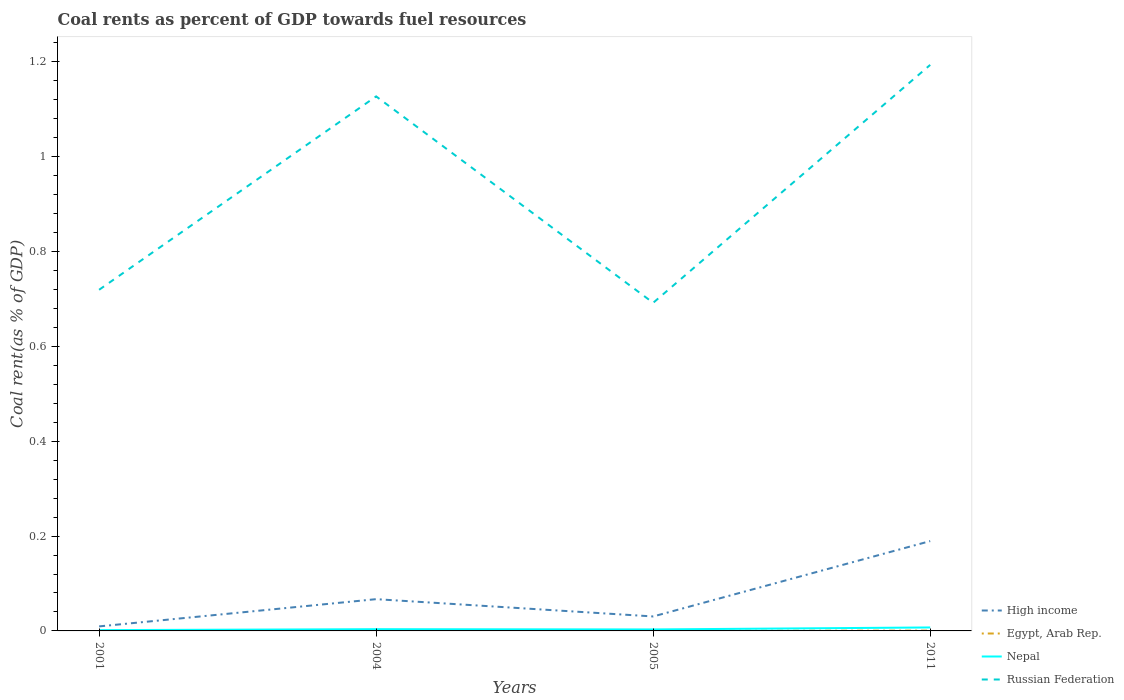Is the number of lines equal to the number of legend labels?
Make the answer very short. Yes. Across all years, what is the maximum coal rent in Nepal?
Make the answer very short. 0. In which year was the coal rent in Russian Federation maximum?
Keep it short and to the point. 2005. What is the total coal rent in High income in the graph?
Offer a very short reply. -0.18. What is the difference between the highest and the second highest coal rent in Nepal?
Offer a very short reply. 0.01. Is the coal rent in High income strictly greater than the coal rent in Nepal over the years?
Make the answer very short. No. How many lines are there?
Give a very brief answer. 4. Are the values on the major ticks of Y-axis written in scientific E-notation?
Offer a terse response. No. How are the legend labels stacked?
Offer a terse response. Vertical. What is the title of the graph?
Provide a succinct answer. Coal rents as percent of GDP towards fuel resources. Does "Syrian Arab Republic" appear as one of the legend labels in the graph?
Your answer should be very brief. No. What is the label or title of the X-axis?
Provide a short and direct response. Years. What is the label or title of the Y-axis?
Give a very brief answer. Coal rent(as % of GDP). What is the Coal rent(as % of GDP) in High income in 2001?
Ensure brevity in your answer.  0.01. What is the Coal rent(as % of GDP) in Egypt, Arab Rep. in 2001?
Your answer should be compact. 1.02739128441411e-6. What is the Coal rent(as % of GDP) in Nepal in 2001?
Offer a very short reply. 0. What is the Coal rent(as % of GDP) of Russian Federation in 2001?
Keep it short and to the point. 0.72. What is the Coal rent(as % of GDP) in High income in 2004?
Your answer should be compact. 0.07. What is the Coal rent(as % of GDP) of Egypt, Arab Rep. in 2004?
Make the answer very short. 0. What is the Coal rent(as % of GDP) of Nepal in 2004?
Your answer should be compact. 0. What is the Coal rent(as % of GDP) in Russian Federation in 2004?
Ensure brevity in your answer.  1.13. What is the Coal rent(as % of GDP) in High income in 2005?
Your answer should be compact. 0.03. What is the Coal rent(as % of GDP) of Egypt, Arab Rep. in 2005?
Provide a short and direct response. 0. What is the Coal rent(as % of GDP) of Nepal in 2005?
Your answer should be very brief. 0. What is the Coal rent(as % of GDP) in Russian Federation in 2005?
Offer a terse response. 0.69. What is the Coal rent(as % of GDP) in High income in 2011?
Offer a terse response. 0.19. What is the Coal rent(as % of GDP) in Egypt, Arab Rep. in 2011?
Provide a short and direct response. 0. What is the Coal rent(as % of GDP) of Nepal in 2011?
Your answer should be very brief. 0.01. What is the Coal rent(as % of GDP) of Russian Federation in 2011?
Give a very brief answer. 1.19. Across all years, what is the maximum Coal rent(as % of GDP) of High income?
Your answer should be very brief. 0.19. Across all years, what is the maximum Coal rent(as % of GDP) in Egypt, Arab Rep.?
Your response must be concise. 0. Across all years, what is the maximum Coal rent(as % of GDP) in Nepal?
Give a very brief answer. 0.01. Across all years, what is the maximum Coal rent(as % of GDP) in Russian Federation?
Keep it short and to the point. 1.19. Across all years, what is the minimum Coal rent(as % of GDP) in High income?
Offer a very short reply. 0.01. Across all years, what is the minimum Coal rent(as % of GDP) of Egypt, Arab Rep.?
Offer a terse response. 1.02739128441411e-6. Across all years, what is the minimum Coal rent(as % of GDP) of Nepal?
Make the answer very short. 0. Across all years, what is the minimum Coal rent(as % of GDP) of Russian Federation?
Ensure brevity in your answer.  0.69. What is the total Coal rent(as % of GDP) in High income in the graph?
Keep it short and to the point. 0.3. What is the total Coal rent(as % of GDP) of Egypt, Arab Rep. in the graph?
Provide a succinct answer. 0. What is the total Coal rent(as % of GDP) in Nepal in the graph?
Your answer should be compact. 0.02. What is the total Coal rent(as % of GDP) in Russian Federation in the graph?
Offer a very short reply. 3.73. What is the difference between the Coal rent(as % of GDP) in High income in 2001 and that in 2004?
Give a very brief answer. -0.06. What is the difference between the Coal rent(as % of GDP) in Egypt, Arab Rep. in 2001 and that in 2004?
Offer a very short reply. -0. What is the difference between the Coal rent(as % of GDP) in Nepal in 2001 and that in 2004?
Provide a short and direct response. -0. What is the difference between the Coal rent(as % of GDP) of Russian Federation in 2001 and that in 2004?
Your answer should be compact. -0.41. What is the difference between the Coal rent(as % of GDP) of High income in 2001 and that in 2005?
Provide a succinct answer. -0.02. What is the difference between the Coal rent(as % of GDP) in Egypt, Arab Rep. in 2001 and that in 2005?
Your answer should be compact. -0. What is the difference between the Coal rent(as % of GDP) of Nepal in 2001 and that in 2005?
Make the answer very short. -0. What is the difference between the Coal rent(as % of GDP) in Russian Federation in 2001 and that in 2005?
Your answer should be very brief. 0.03. What is the difference between the Coal rent(as % of GDP) of High income in 2001 and that in 2011?
Your answer should be very brief. -0.18. What is the difference between the Coal rent(as % of GDP) of Egypt, Arab Rep. in 2001 and that in 2011?
Keep it short and to the point. -0. What is the difference between the Coal rent(as % of GDP) of Nepal in 2001 and that in 2011?
Give a very brief answer. -0.01. What is the difference between the Coal rent(as % of GDP) of Russian Federation in 2001 and that in 2011?
Your answer should be very brief. -0.47. What is the difference between the Coal rent(as % of GDP) of High income in 2004 and that in 2005?
Provide a short and direct response. 0.04. What is the difference between the Coal rent(as % of GDP) of Egypt, Arab Rep. in 2004 and that in 2005?
Make the answer very short. 0. What is the difference between the Coal rent(as % of GDP) of Nepal in 2004 and that in 2005?
Give a very brief answer. 0. What is the difference between the Coal rent(as % of GDP) in Russian Federation in 2004 and that in 2005?
Offer a terse response. 0.44. What is the difference between the Coal rent(as % of GDP) of High income in 2004 and that in 2011?
Give a very brief answer. -0.12. What is the difference between the Coal rent(as % of GDP) of Nepal in 2004 and that in 2011?
Offer a terse response. -0. What is the difference between the Coal rent(as % of GDP) of Russian Federation in 2004 and that in 2011?
Make the answer very short. -0.07. What is the difference between the Coal rent(as % of GDP) of High income in 2005 and that in 2011?
Your response must be concise. -0.16. What is the difference between the Coal rent(as % of GDP) in Egypt, Arab Rep. in 2005 and that in 2011?
Your response must be concise. -0. What is the difference between the Coal rent(as % of GDP) in Nepal in 2005 and that in 2011?
Your answer should be compact. -0. What is the difference between the Coal rent(as % of GDP) in Russian Federation in 2005 and that in 2011?
Keep it short and to the point. -0.5. What is the difference between the Coal rent(as % of GDP) in High income in 2001 and the Coal rent(as % of GDP) in Egypt, Arab Rep. in 2004?
Your answer should be compact. 0.01. What is the difference between the Coal rent(as % of GDP) of High income in 2001 and the Coal rent(as % of GDP) of Nepal in 2004?
Ensure brevity in your answer.  0.01. What is the difference between the Coal rent(as % of GDP) of High income in 2001 and the Coal rent(as % of GDP) of Russian Federation in 2004?
Give a very brief answer. -1.12. What is the difference between the Coal rent(as % of GDP) in Egypt, Arab Rep. in 2001 and the Coal rent(as % of GDP) in Nepal in 2004?
Provide a succinct answer. -0. What is the difference between the Coal rent(as % of GDP) of Egypt, Arab Rep. in 2001 and the Coal rent(as % of GDP) of Russian Federation in 2004?
Ensure brevity in your answer.  -1.13. What is the difference between the Coal rent(as % of GDP) in Nepal in 2001 and the Coal rent(as % of GDP) in Russian Federation in 2004?
Provide a short and direct response. -1.13. What is the difference between the Coal rent(as % of GDP) of High income in 2001 and the Coal rent(as % of GDP) of Egypt, Arab Rep. in 2005?
Ensure brevity in your answer.  0.01. What is the difference between the Coal rent(as % of GDP) in High income in 2001 and the Coal rent(as % of GDP) in Nepal in 2005?
Ensure brevity in your answer.  0.01. What is the difference between the Coal rent(as % of GDP) in High income in 2001 and the Coal rent(as % of GDP) in Russian Federation in 2005?
Offer a terse response. -0.68. What is the difference between the Coal rent(as % of GDP) in Egypt, Arab Rep. in 2001 and the Coal rent(as % of GDP) in Nepal in 2005?
Your response must be concise. -0. What is the difference between the Coal rent(as % of GDP) in Egypt, Arab Rep. in 2001 and the Coal rent(as % of GDP) in Russian Federation in 2005?
Provide a succinct answer. -0.69. What is the difference between the Coal rent(as % of GDP) of Nepal in 2001 and the Coal rent(as % of GDP) of Russian Federation in 2005?
Provide a succinct answer. -0.69. What is the difference between the Coal rent(as % of GDP) in High income in 2001 and the Coal rent(as % of GDP) in Egypt, Arab Rep. in 2011?
Keep it short and to the point. 0.01. What is the difference between the Coal rent(as % of GDP) of High income in 2001 and the Coal rent(as % of GDP) of Nepal in 2011?
Your answer should be very brief. 0. What is the difference between the Coal rent(as % of GDP) in High income in 2001 and the Coal rent(as % of GDP) in Russian Federation in 2011?
Ensure brevity in your answer.  -1.18. What is the difference between the Coal rent(as % of GDP) in Egypt, Arab Rep. in 2001 and the Coal rent(as % of GDP) in Nepal in 2011?
Keep it short and to the point. -0.01. What is the difference between the Coal rent(as % of GDP) in Egypt, Arab Rep. in 2001 and the Coal rent(as % of GDP) in Russian Federation in 2011?
Provide a short and direct response. -1.19. What is the difference between the Coal rent(as % of GDP) of Nepal in 2001 and the Coal rent(as % of GDP) of Russian Federation in 2011?
Offer a terse response. -1.19. What is the difference between the Coal rent(as % of GDP) of High income in 2004 and the Coal rent(as % of GDP) of Egypt, Arab Rep. in 2005?
Give a very brief answer. 0.07. What is the difference between the Coal rent(as % of GDP) in High income in 2004 and the Coal rent(as % of GDP) in Nepal in 2005?
Your response must be concise. 0.06. What is the difference between the Coal rent(as % of GDP) in High income in 2004 and the Coal rent(as % of GDP) in Russian Federation in 2005?
Provide a succinct answer. -0.62. What is the difference between the Coal rent(as % of GDP) of Egypt, Arab Rep. in 2004 and the Coal rent(as % of GDP) of Nepal in 2005?
Offer a very short reply. -0. What is the difference between the Coal rent(as % of GDP) of Egypt, Arab Rep. in 2004 and the Coal rent(as % of GDP) of Russian Federation in 2005?
Keep it short and to the point. -0.69. What is the difference between the Coal rent(as % of GDP) of Nepal in 2004 and the Coal rent(as % of GDP) of Russian Federation in 2005?
Your answer should be very brief. -0.69. What is the difference between the Coal rent(as % of GDP) in High income in 2004 and the Coal rent(as % of GDP) in Egypt, Arab Rep. in 2011?
Give a very brief answer. 0.07. What is the difference between the Coal rent(as % of GDP) of High income in 2004 and the Coal rent(as % of GDP) of Nepal in 2011?
Ensure brevity in your answer.  0.06. What is the difference between the Coal rent(as % of GDP) in High income in 2004 and the Coal rent(as % of GDP) in Russian Federation in 2011?
Your answer should be very brief. -1.13. What is the difference between the Coal rent(as % of GDP) of Egypt, Arab Rep. in 2004 and the Coal rent(as % of GDP) of Nepal in 2011?
Offer a terse response. -0.01. What is the difference between the Coal rent(as % of GDP) in Egypt, Arab Rep. in 2004 and the Coal rent(as % of GDP) in Russian Federation in 2011?
Give a very brief answer. -1.19. What is the difference between the Coal rent(as % of GDP) in Nepal in 2004 and the Coal rent(as % of GDP) in Russian Federation in 2011?
Provide a short and direct response. -1.19. What is the difference between the Coal rent(as % of GDP) in High income in 2005 and the Coal rent(as % of GDP) in Egypt, Arab Rep. in 2011?
Your answer should be compact. 0.03. What is the difference between the Coal rent(as % of GDP) in High income in 2005 and the Coal rent(as % of GDP) in Nepal in 2011?
Your response must be concise. 0.02. What is the difference between the Coal rent(as % of GDP) in High income in 2005 and the Coal rent(as % of GDP) in Russian Federation in 2011?
Your answer should be compact. -1.16. What is the difference between the Coal rent(as % of GDP) in Egypt, Arab Rep. in 2005 and the Coal rent(as % of GDP) in Nepal in 2011?
Keep it short and to the point. -0.01. What is the difference between the Coal rent(as % of GDP) of Egypt, Arab Rep. in 2005 and the Coal rent(as % of GDP) of Russian Federation in 2011?
Provide a short and direct response. -1.19. What is the difference between the Coal rent(as % of GDP) in Nepal in 2005 and the Coal rent(as % of GDP) in Russian Federation in 2011?
Offer a very short reply. -1.19. What is the average Coal rent(as % of GDP) in High income per year?
Offer a terse response. 0.07. What is the average Coal rent(as % of GDP) in Egypt, Arab Rep. per year?
Offer a very short reply. 0. What is the average Coal rent(as % of GDP) in Nepal per year?
Your response must be concise. 0. What is the average Coal rent(as % of GDP) of Russian Federation per year?
Your answer should be very brief. 0.93. In the year 2001, what is the difference between the Coal rent(as % of GDP) in High income and Coal rent(as % of GDP) in Egypt, Arab Rep.?
Provide a short and direct response. 0.01. In the year 2001, what is the difference between the Coal rent(as % of GDP) in High income and Coal rent(as % of GDP) in Nepal?
Keep it short and to the point. 0.01. In the year 2001, what is the difference between the Coal rent(as % of GDP) of High income and Coal rent(as % of GDP) of Russian Federation?
Provide a short and direct response. -0.71. In the year 2001, what is the difference between the Coal rent(as % of GDP) in Egypt, Arab Rep. and Coal rent(as % of GDP) in Nepal?
Make the answer very short. -0. In the year 2001, what is the difference between the Coal rent(as % of GDP) of Egypt, Arab Rep. and Coal rent(as % of GDP) of Russian Federation?
Ensure brevity in your answer.  -0.72. In the year 2001, what is the difference between the Coal rent(as % of GDP) in Nepal and Coal rent(as % of GDP) in Russian Federation?
Make the answer very short. -0.72. In the year 2004, what is the difference between the Coal rent(as % of GDP) in High income and Coal rent(as % of GDP) in Egypt, Arab Rep.?
Offer a very short reply. 0.07. In the year 2004, what is the difference between the Coal rent(as % of GDP) of High income and Coal rent(as % of GDP) of Nepal?
Provide a short and direct response. 0.06. In the year 2004, what is the difference between the Coal rent(as % of GDP) in High income and Coal rent(as % of GDP) in Russian Federation?
Make the answer very short. -1.06. In the year 2004, what is the difference between the Coal rent(as % of GDP) of Egypt, Arab Rep. and Coal rent(as % of GDP) of Nepal?
Keep it short and to the point. -0. In the year 2004, what is the difference between the Coal rent(as % of GDP) in Egypt, Arab Rep. and Coal rent(as % of GDP) in Russian Federation?
Make the answer very short. -1.13. In the year 2004, what is the difference between the Coal rent(as % of GDP) in Nepal and Coal rent(as % of GDP) in Russian Federation?
Provide a short and direct response. -1.12. In the year 2005, what is the difference between the Coal rent(as % of GDP) of High income and Coal rent(as % of GDP) of Egypt, Arab Rep.?
Offer a very short reply. 0.03. In the year 2005, what is the difference between the Coal rent(as % of GDP) of High income and Coal rent(as % of GDP) of Nepal?
Provide a short and direct response. 0.03. In the year 2005, what is the difference between the Coal rent(as % of GDP) in High income and Coal rent(as % of GDP) in Russian Federation?
Make the answer very short. -0.66. In the year 2005, what is the difference between the Coal rent(as % of GDP) in Egypt, Arab Rep. and Coal rent(as % of GDP) in Nepal?
Give a very brief answer. -0. In the year 2005, what is the difference between the Coal rent(as % of GDP) of Egypt, Arab Rep. and Coal rent(as % of GDP) of Russian Federation?
Your answer should be very brief. -0.69. In the year 2005, what is the difference between the Coal rent(as % of GDP) of Nepal and Coal rent(as % of GDP) of Russian Federation?
Give a very brief answer. -0.69. In the year 2011, what is the difference between the Coal rent(as % of GDP) in High income and Coal rent(as % of GDP) in Egypt, Arab Rep.?
Provide a succinct answer. 0.19. In the year 2011, what is the difference between the Coal rent(as % of GDP) of High income and Coal rent(as % of GDP) of Nepal?
Ensure brevity in your answer.  0.18. In the year 2011, what is the difference between the Coal rent(as % of GDP) of High income and Coal rent(as % of GDP) of Russian Federation?
Offer a very short reply. -1. In the year 2011, what is the difference between the Coal rent(as % of GDP) of Egypt, Arab Rep. and Coal rent(as % of GDP) of Nepal?
Make the answer very short. -0.01. In the year 2011, what is the difference between the Coal rent(as % of GDP) in Egypt, Arab Rep. and Coal rent(as % of GDP) in Russian Federation?
Offer a very short reply. -1.19. In the year 2011, what is the difference between the Coal rent(as % of GDP) in Nepal and Coal rent(as % of GDP) in Russian Federation?
Offer a very short reply. -1.19. What is the ratio of the Coal rent(as % of GDP) of High income in 2001 to that in 2004?
Provide a succinct answer. 0.14. What is the ratio of the Coal rent(as % of GDP) in Egypt, Arab Rep. in 2001 to that in 2004?
Keep it short and to the point. 0. What is the ratio of the Coal rent(as % of GDP) in Nepal in 2001 to that in 2004?
Your answer should be very brief. 0.46. What is the ratio of the Coal rent(as % of GDP) of Russian Federation in 2001 to that in 2004?
Offer a very short reply. 0.64. What is the ratio of the Coal rent(as % of GDP) in High income in 2001 to that in 2005?
Provide a succinct answer. 0.31. What is the ratio of the Coal rent(as % of GDP) in Egypt, Arab Rep. in 2001 to that in 2005?
Provide a short and direct response. 0. What is the ratio of the Coal rent(as % of GDP) in Nepal in 2001 to that in 2005?
Provide a short and direct response. 0.54. What is the ratio of the Coal rent(as % of GDP) of Russian Federation in 2001 to that in 2005?
Keep it short and to the point. 1.04. What is the ratio of the Coal rent(as % of GDP) in High income in 2001 to that in 2011?
Make the answer very short. 0.05. What is the ratio of the Coal rent(as % of GDP) of Egypt, Arab Rep. in 2001 to that in 2011?
Offer a very short reply. 0. What is the ratio of the Coal rent(as % of GDP) of Nepal in 2001 to that in 2011?
Provide a succinct answer. 0.23. What is the ratio of the Coal rent(as % of GDP) of Russian Federation in 2001 to that in 2011?
Your response must be concise. 0.6. What is the ratio of the Coal rent(as % of GDP) of High income in 2004 to that in 2005?
Give a very brief answer. 2.2. What is the ratio of the Coal rent(as % of GDP) of Egypt, Arab Rep. in 2004 to that in 2005?
Keep it short and to the point. 2.83. What is the ratio of the Coal rent(as % of GDP) of Nepal in 2004 to that in 2005?
Offer a very short reply. 1.16. What is the ratio of the Coal rent(as % of GDP) in Russian Federation in 2004 to that in 2005?
Ensure brevity in your answer.  1.63. What is the ratio of the Coal rent(as % of GDP) of High income in 2004 to that in 2011?
Keep it short and to the point. 0.35. What is the ratio of the Coal rent(as % of GDP) in Egypt, Arab Rep. in 2004 to that in 2011?
Keep it short and to the point. 1.13. What is the ratio of the Coal rent(as % of GDP) in Nepal in 2004 to that in 2011?
Ensure brevity in your answer.  0.5. What is the ratio of the Coal rent(as % of GDP) of Russian Federation in 2004 to that in 2011?
Keep it short and to the point. 0.94. What is the ratio of the Coal rent(as % of GDP) in High income in 2005 to that in 2011?
Offer a very short reply. 0.16. What is the ratio of the Coal rent(as % of GDP) of Egypt, Arab Rep. in 2005 to that in 2011?
Make the answer very short. 0.4. What is the ratio of the Coal rent(as % of GDP) in Nepal in 2005 to that in 2011?
Provide a succinct answer. 0.43. What is the ratio of the Coal rent(as % of GDP) of Russian Federation in 2005 to that in 2011?
Provide a short and direct response. 0.58. What is the difference between the highest and the second highest Coal rent(as % of GDP) in High income?
Provide a succinct answer. 0.12. What is the difference between the highest and the second highest Coal rent(as % of GDP) of Nepal?
Your response must be concise. 0. What is the difference between the highest and the second highest Coal rent(as % of GDP) of Russian Federation?
Your answer should be very brief. 0.07. What is the difference between the highest and the lowest Coal rent(as % of GDP) in High income?
Offer a very short reply. 0.18. What is the difference between the highest and the lowest Coal rent(as % of GDP) in Egypt, Arab Rep.?
Provide a short and direct response. 0. What is the difference between the highest and the lowest Coal rent(as % of GDP) of Nepal?
Your answer should be very brief. 0.01. What is the difference between the highest and the lowest Coal rent(as % of GDP) in Russian Federation?
Offer a terse response. 0.5. 